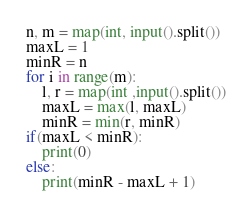<code> <loc_0><loc_0><loc_500><loc_500><_Python_>n, m = map(int, input().split())
maxL = 1
minR = n
for i in range(m):
    l, r = map(int ,input().split())
    maxL = max(l, maxL)
    minR = min(r, minR)
if(maxL < minR):
    print(0)
else:
    print(minR - maxL + 1)
</code> 